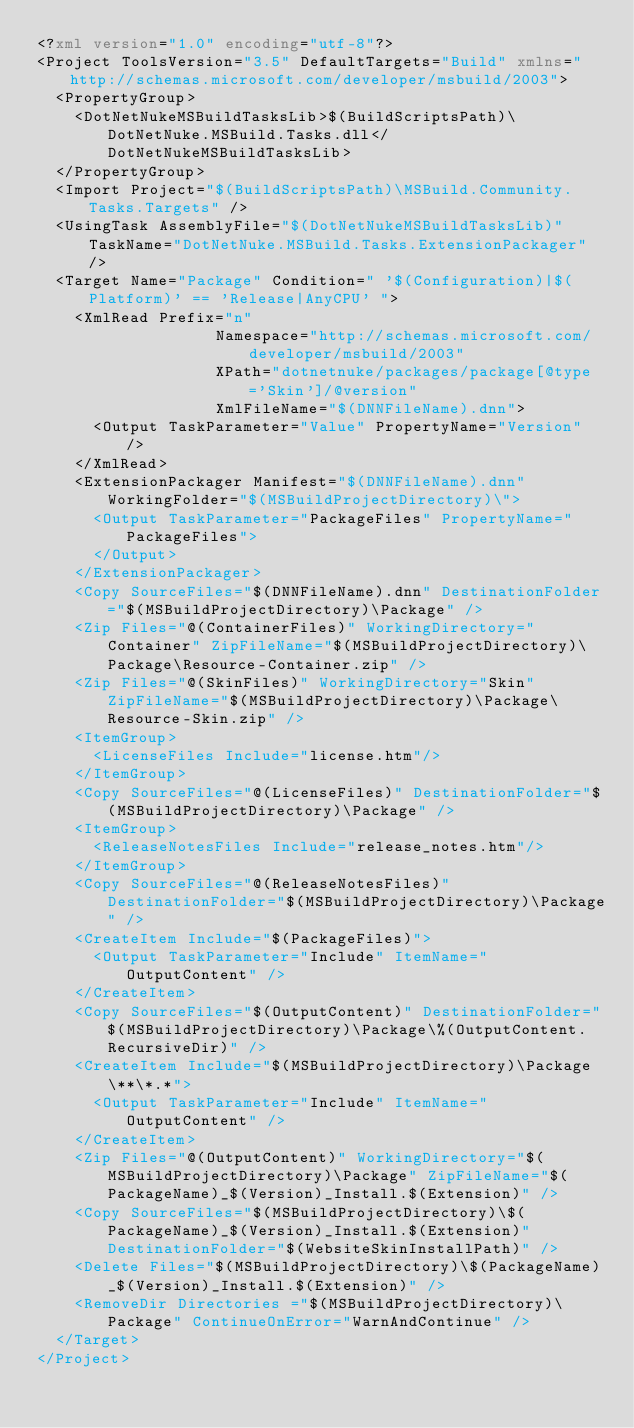Convert code to text. <code><loc_0><loc_0><loc_500><loc_500><_XML_><?xml version="1.0" encoding="utf-8"?>
<Project ToolsVersion="3.5" DefaultTargets="Build" xmlns="http://schemas.microsoft.com/developer/msbuild/2003">
  <PropertyGroup>
    <DotNetNukeMSBuildTasksLib>$(BuildScriptsPath)\DotNetNuke.MSBuild.Tasks.dll</DotNetNukeMSBuildTasksLib>
  </PropertyGroup>
  <Import Project="$(BuildScriptsPath)\MSBuild.Community.Tasks.Targets" />
  <UsingTask AssemblyFile="$(DotNetNukeMSBuildTasksLib)" TaskName="DotNetNuke.MSBuild.Tasks.ExtensionPackager" />
  <Target Name="Package" Condition=" '$(Configuration)|$(Platform)' == 'Release|AnyCPU' ">
    <XmlRead Prefix="n"
                   Namespace="http://schemas.microsoft.com/developer/msbuild/2003"
                   XPath="dotnetnuke/packages/package[@type='Skin']/@version"
                   XmlFileName="$(DNNFileName).dnn">
      <Output TaskParameter="Value" PropertyName="Version" />
    </XmlRead>
    <ExtensionPackager Manifest="$(DNNFileName).dnn" WorkingFolder="$(MSBuildProjectDirectory)\">
      <Output TaskParameter="PackageFiles" PropertyName="PackageFiles">
      </Output>
    </ExtensionPackager>
    <Copy SourceFiles="$(DNNFileName).dnn" DestinationFolder="$(MSBuildProjectDirectory)\Package" />
    <Zip Files="@(ContainerFiles)" WorkingDirectory="Container" ZipFileName="$(MSBuildProjectDirectory)\Package\Resource-Container.zip" />
    <Zip Files="@(SkinFiles)" WorkingDirectory="Skin" ZipFileName="$(MSBuildProjectDirectory)\Package\Resource-Skin.zip" />
    <ItemGroup>
      <LicenseFiles Include="license.htm"/>
    </ItemGroup>
    <Copy SourceFiles="@(LicenseFiles)" DestinationFolder="$(MSBuildProjectDirectory)\Package" />
    <ItemGroup>
      <ReleaseNotesFiles Include="release_notes.htm"/>
    </ItemGroup>
    <Copy SourceFiles="@(ReleaseNotesFiles)" DestinationFolder="$(MSBuildProjectDirectory)\Package" />
    <CreateItem Include="$(PackageFiles)">
      <Output TaskParameter="Include" ItemName="OutputContent" />
    </CreateItem>
    <Copy SourceFiles="$(OutputContent)" DestinationFolder="$(MSBuildProjectDirectory)\Package\%(OutputContent.RecursiveDir)" />
    <CreateItem Include="$(MSBuildProjectDirectory)\Package\**\*.*">
      <Output TaskParameter="Include" ItemName="OutputContent" />
    </CreateItem>
    <Zip Files="@(OutputContent)" WorkingDirectory="$(MSBuildProjectDirectory)\Package" ZipFileName="$(PackageName)_$(Version)_Install.$(Extension)" />
    <Copy SourceFiles="$(MSBuildProjectDirectory)\$(PackageName)_$(Version)_Install.$(Extension)" DestinationFolder="$(WebsiteSkinInstallPath)" />
    <Delete Files="$(MSBuildProjectDirectory)\$(PackageName)_$(Version)_Install.$(Extension)" />
    <RemoveDir Directories ="$(MSBuildProjectDirectory)\Package" ContinueOnError="WarnAndContinue" />
  </Target>
</Project></code> 